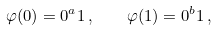Convert formula to latex. <formula><loc_0><loc_0><loc_500><loc_500>\varphi ( 0 ) = 0 ^ { a } 1 \, , \quad \varphi ( 1 ) = 0 ^ { b } 1 \, ,</formula> 